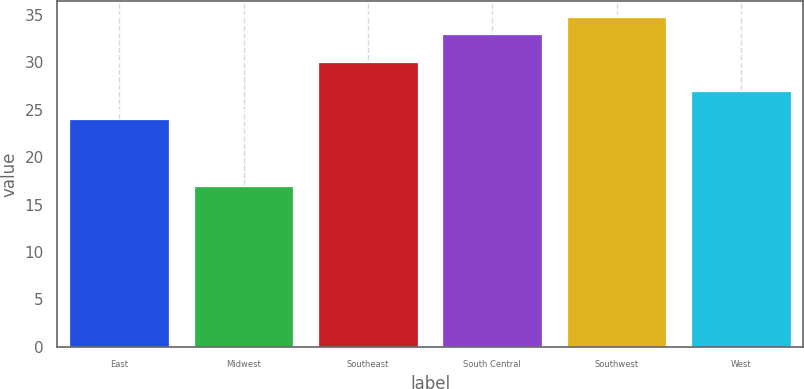Convert chart to OTSL. <chart><loc_0><loc_0><loc_500><loc_500><bar_chart><fcel>East<fcel>Midwest<fcel>Southeast<fcel>South Central<fcel>Southwest<fcel>West<nl><fcel>24<fcel>17<fcel>30<fcel>33<fcel>34.7<fcel>27<nl></chart> 